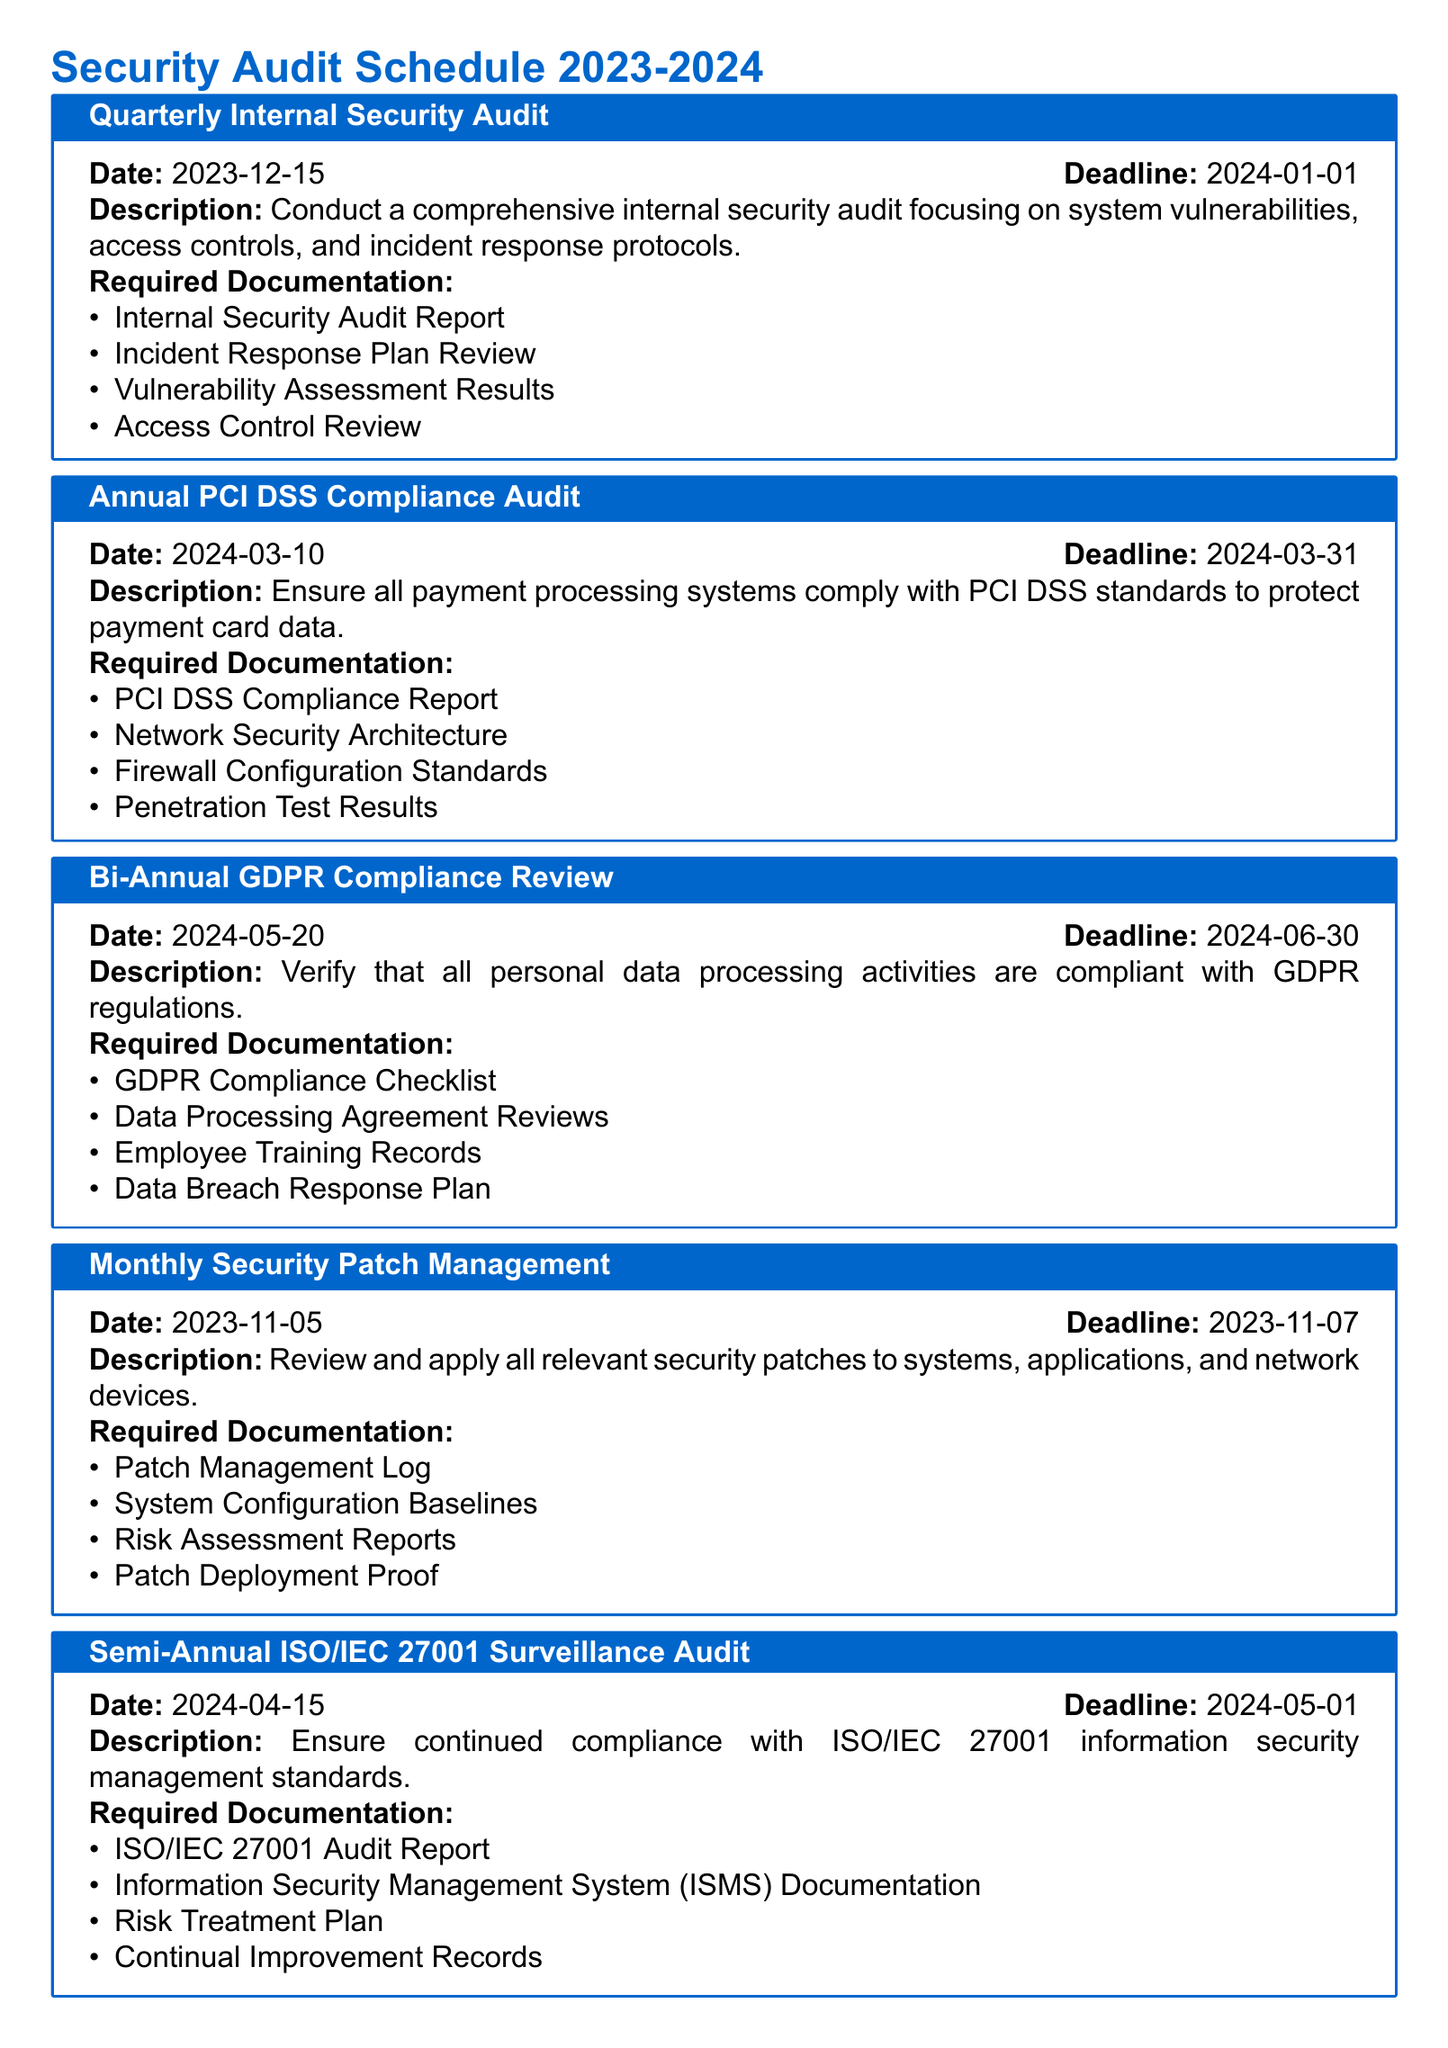What is the date of the Quarterly Internal Security Audit? The date for the Quarterly Internal Security Audit is specified in the document as 2023-12-15.
Answer: 2023-12-15 What is the deadline for the Annual PCI DSS Compliance Audit? The document states that the deadline for the Annual PCI DSS Compliance Audit is 2024-03-31.
Answer: 2024-03-31 How often is the Security Patch Management scheduled? The document indicates that the Security Patch Management occurs monthly, specifically noted as "Monthly Security Patch Management."
Answer: Monthly What required documentation is needed for the Bi-Annual GDPR Compliance Review? The document lists the required documentation for the Bi-Annual GDPR Compliance Review, including the GDPR Compliance Checklist, so the answer focuses on that specific list.
Answer: GDPR Compliance Checklist, Data Processing Agreement Reviews, Employee Training Records, Data Breach Response Plan How many compliance audits are scheduled between December 2023 and June 2024? The document details three compliance audits within this timeframe: the Quarterly Internal Security Audit, the Annual PCI DSS Compliance Audit, and the Bi-Annual GDPR Compliance Review.
Answer: Three 